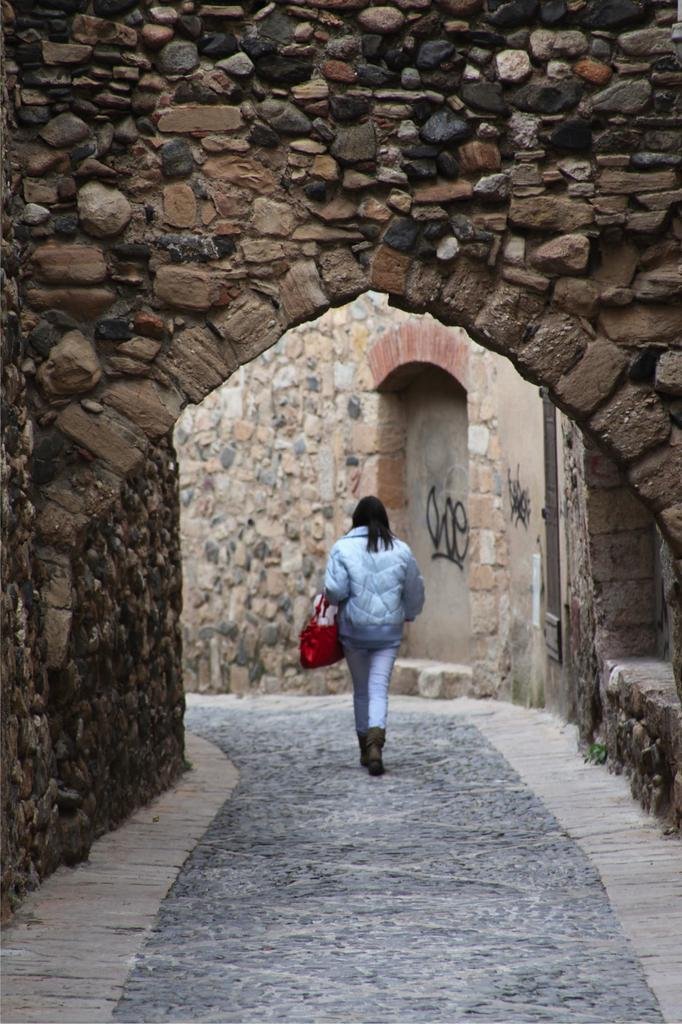What is the main subject of the image? There is a person walking in the image. Where is the person located in the image? The person is in the middle of the image. What can be seen at the top of the image? There is a stone wall at the top of the image. How many parcels can be seen being delivered by the bikes in the image? There are no bikes or parcels present in the image; it only features a person walking and a stone wall. What type of society is depicted in the image? The image does not depict a society; it only shows a person walking and a stone wall. 